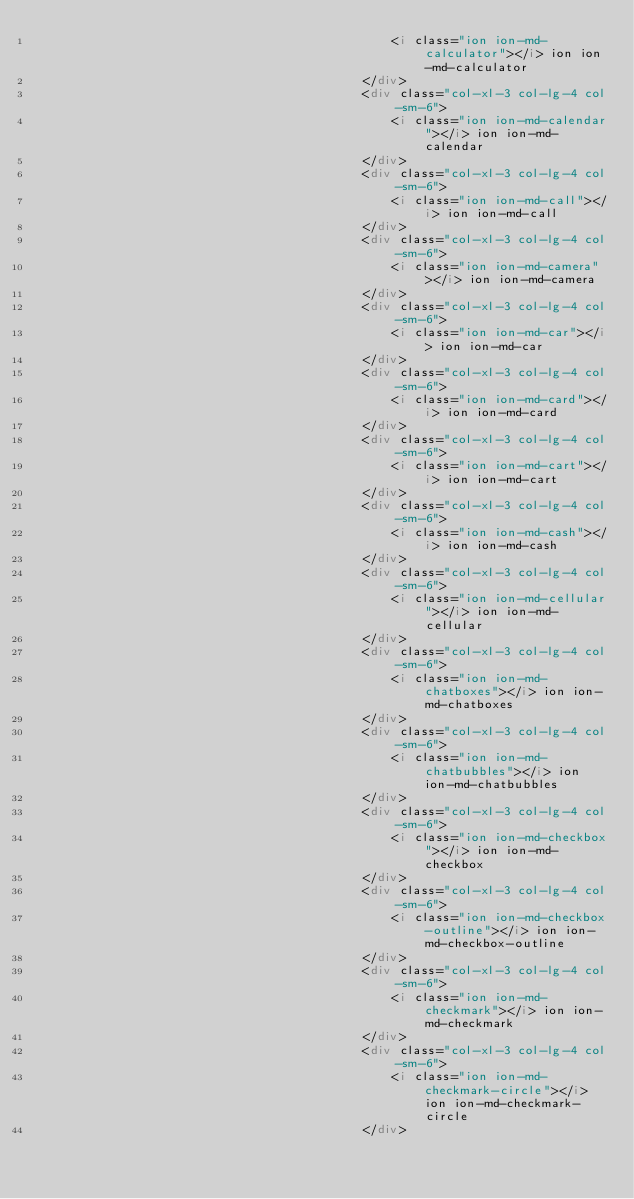Convert code to text. <code><loc_0><loc_0><loc_500><loc_500><_HTML_>                                                <i class="ion ion-md-calculator"></i> ion ion-md-calculator
                                            </div>
                                            <div class="col-xl-3 col-lg-4 col-sm-6">
                                                <i class="ion ion-md-calendar"></i> ion ion-md-calendar
                                            </div>
                                            <div class="col-xl-3 col-lg-4 col-sm-6">
                                                <i class="ion ion-md-call"></i> ion ion-md-call
                                            </div>
                                            <div class="col-xl-3 col-lg-4 col-sm-6">
                                                <i class="ion ion-md-camera"></i> ion ion-md-camera
                                            </div>
                                            <div class="col-xl-3 col-lg-4 col-sm-6">
                                                <i class="ion ion-md-car"></i> ion ion-md-car
                                            </div>
                                            <div class="col-xl-3 col-lg-4 col-sm-6">
                                                <i class="ion ion-md-card"></i> ion ion-md-card
                                            </div>
                                            <div class="col-xl-3 col-lg-4 col-sm-6">
                                                <i class="ion ion-md-cart"></i> ion ion-md-cart
                                            </div>
                                            <div class="col-xl-3 col-lg-4 col-sm-6">
                                                <i class="ion ion-md-cash"></i> ion ion-md-cash
                                            </div>
                                            <div class="col-xl-3 col-lg-4 col-sm-6">
                                                <i class="ion ion-md-cellular"></i> ion ion-md-cellular
                                            </div>
                                            <div class="col-xl-3 col-lg-4 col-sm-6">
                                                <i class="ion ion-md-chatboxes"></i> ion ion-md-chatboxes
                                            </div>
                                            <div class="col-xl-3 col-lg-4 col-sm-6">
                                                <i class="ion ion-md-chatbubbles"></i> ion ion-md-chatbubbles
                                            </div>
                                            <div class="col-xl-3 col-lg-4 col-sm-6">
                                                <i class="ion ion-md-checkbox"></i> ion ion-md-checkbox
                                            </div>
                                            <div class="col-xl-3 col-lg-4 col-sm-6">
                                                <i class="ion ion-md-checkbox-outline"></i> ion ion-md-checkbox-outline
                                            </div>
                                            <div class="col-xl-3 col-lg-4 col-sm-6">
                                                <i class="ion ion-md-checkmark"></i> ion ion-md-checkmark
                                            </div>
                                            <div class="col-xl-3 col-lg-4 col-sm-6">
                                                <i class="ion ion-md-checkmark-circle"></i> ion ion-md-checkmark-circle
                                            </div></code> 